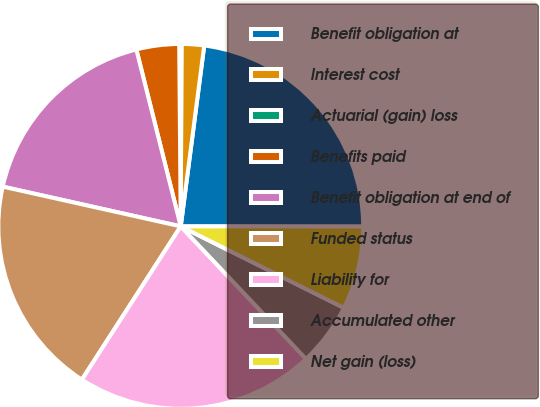<chart> <loc_0><loc_0><loc_500><loc_500><pie_chart><fcel>Benefit obligation at<fcel>Interest cost<fcel>Actuarial (gain) loss<fcel>Benefits paid<fcel>Benefit obligation at end of<fcel>Funded status<fcel>Liability for<fcel>Accumulated other<fcel>Net gain (loss)<nl><fcel>22.96%<fcel>1.99%<fcel>0.2%<fcel>3.78%<fcel>17.59%<fcel>19.38%<fcel>21.17%<fcel>5.57%<fcel>7.36%<nl></chart> 